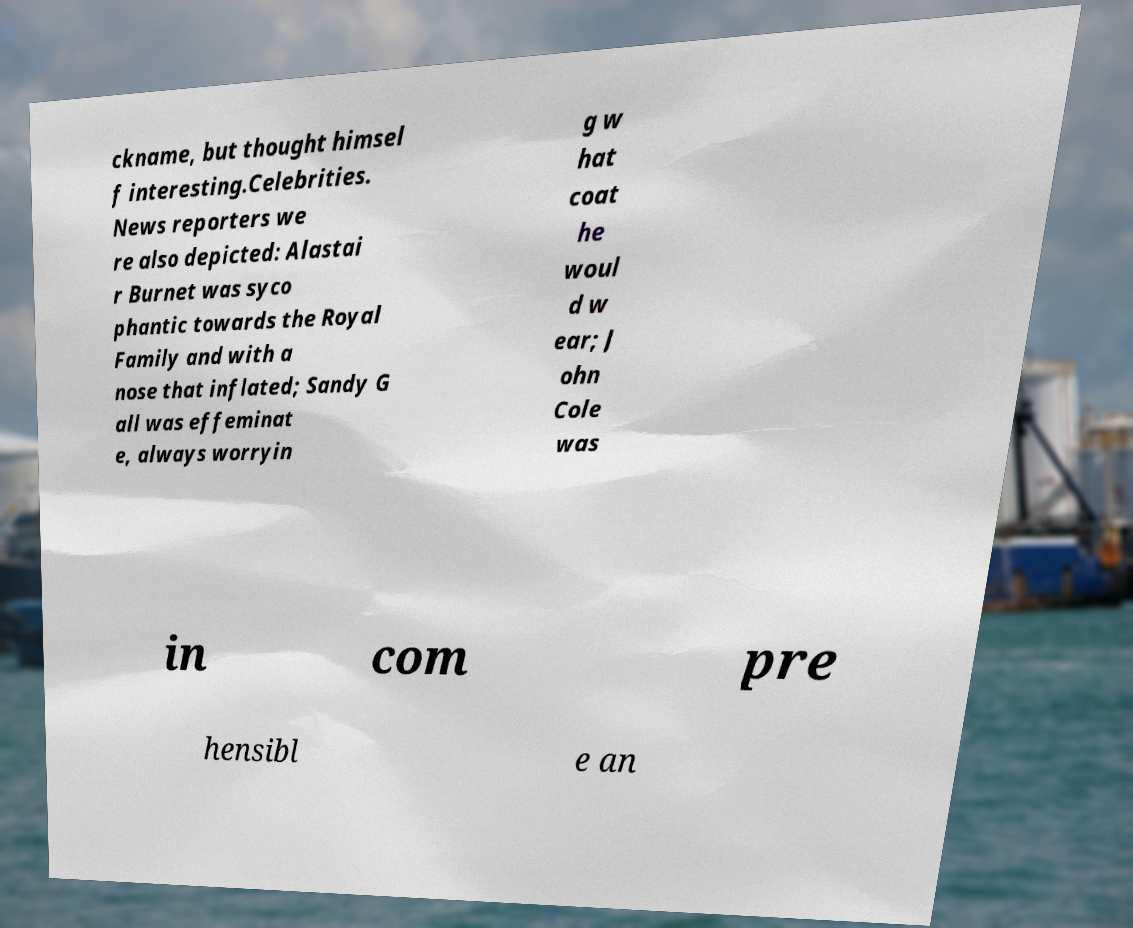There's text embedded in this image that I need extracted. Can you transcribe it verbatim? ckname, but thought himsel f interesting.Celebrities. News reporters we re also depicted: Alastai r Burnet was syco phantic towards the Royal Family and with a nose that inflated; Sandy G all was effeminat e, always worryin g w hat coat he woul d w ear; J ohn Cole was in com pre hensibl e an 